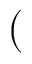Convert formula to latex. <formula><loc_0><loc_0><loc_500><loc_500>(</formula> 